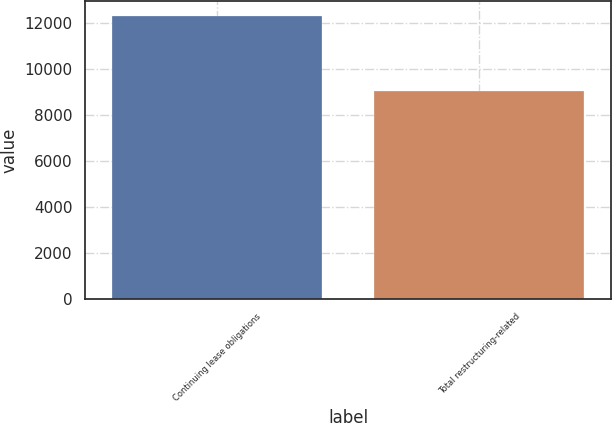Convert chart to OTSL. <chart><loc_0><loc_0><loc_500><loc_500><bar_chart><fcel>Continuing lease obligations<fcel>Total restructuring-related<nl><fcel>12304<fcel>9047<nl></chart> 